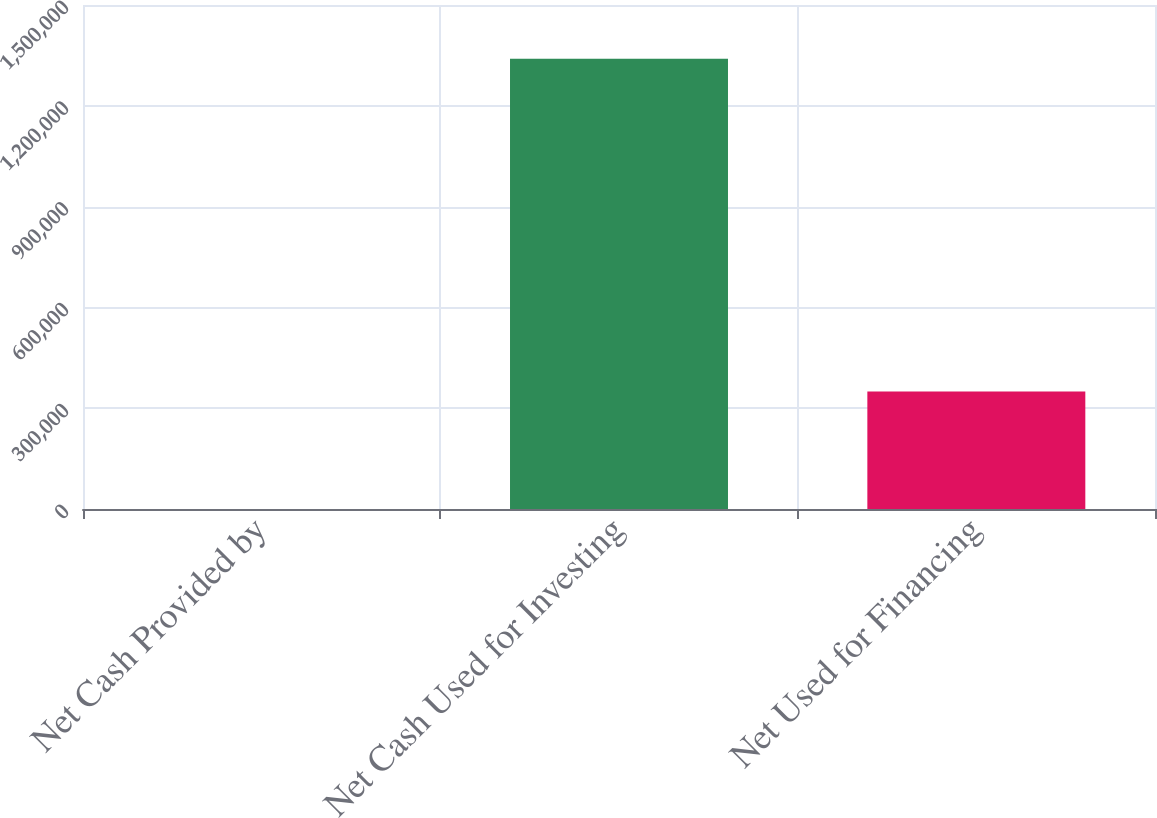Convert chart to OTSL. <chart><loc_0><loc_0><loc_500><loc_500><bar_chart><fcel>Net Cash Provided by<fcel>Net Cash Used for Investing<fcel>Net Used for Financing<nl><fcel>30.2<fcel>1.33969e+06<fcel>349627<nl></chart> 